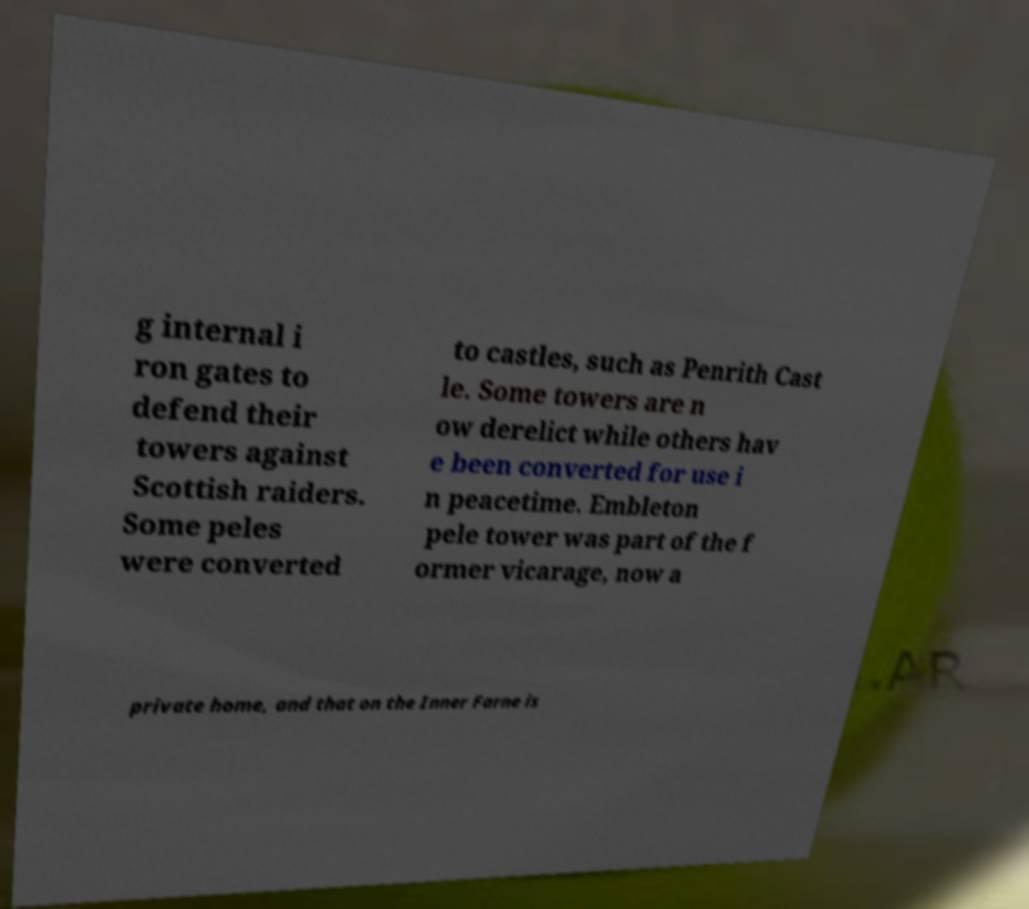Can you accurately transcribe the text from the provided image for me? g internal i ron gates to defend their towers against Scottish raiders. Some peles were converted to castles, such as Penrith Cast le. Some towers are n ow derelict while others hav e been converted for use i n peacetime. Embleton pele tower was part of the f ormer vicarage, now a private home, and that on the Inner Farne is 